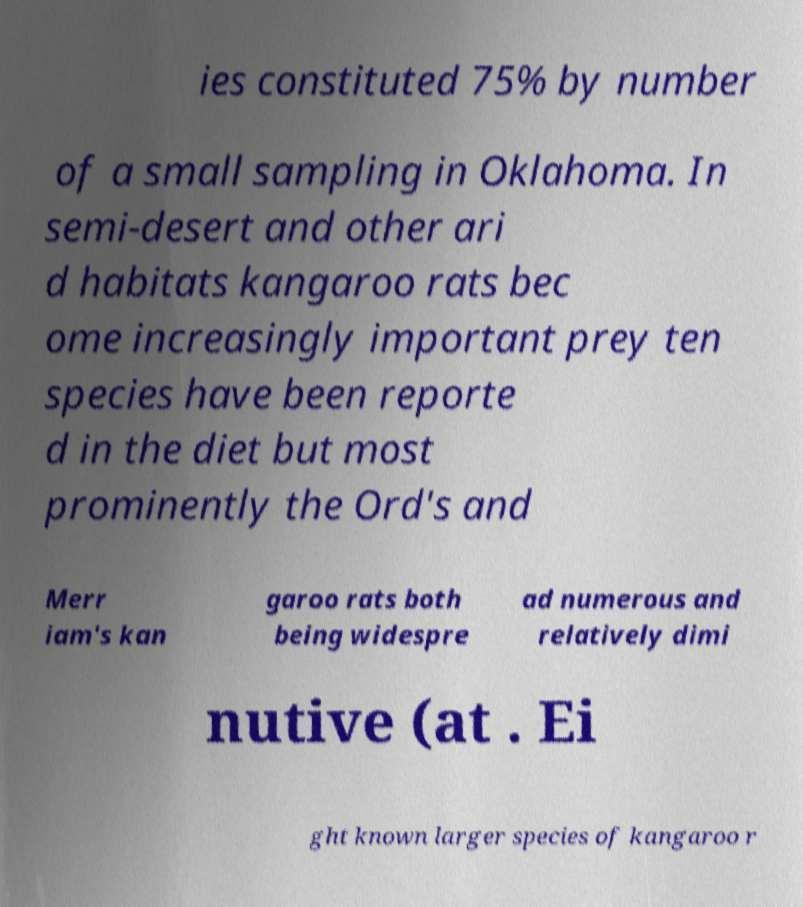Could you assist in decoding the text presented in this image and type it out clearly? ies constituted 75% by number of a small sampling in Oklahoma. In semi-desert and other ari d habitats kangaroo rats bec ome increasingly important prey ten species have been reporte d in the diet but most prominently the Ord's and Merr iam's kan garoo rats both being widespre ad numerous and relatively dimi nutive (at . Ei ght known larger species of kangaroo r 